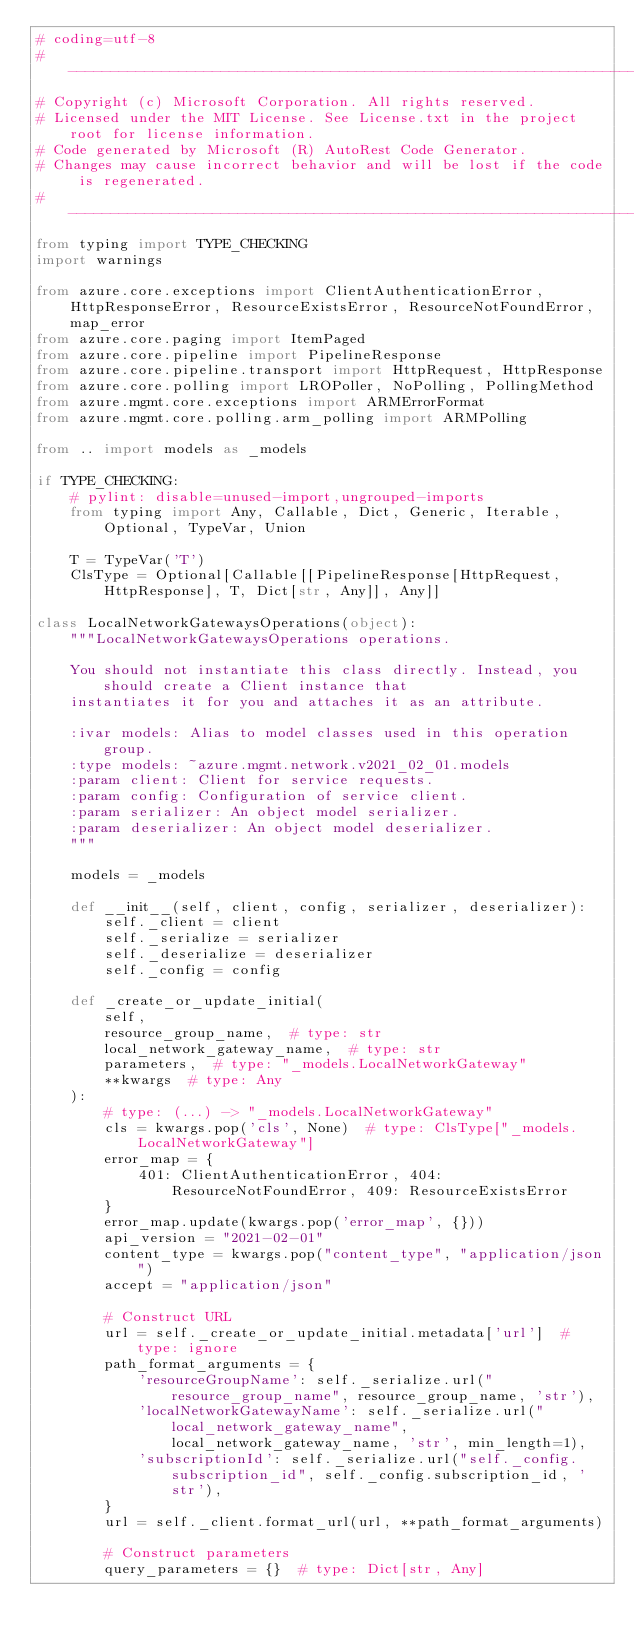<code> <loc_0><loc_0><loc_500><loc_500><_Python_># coding=utf-8
# --------------------------------------------------------------------------
# Copyright (c) Microsoft Corporation. All rights reserved.
# Licensed under the MIT License. See License.txt in the project root for license information.
# Code generated by Microsoft (R) AutoRest Code Generator.
# Changes may cause incorrect behavior and will be lost if the code is regenerated.
# --------------------------------------------------------------------------
from typing import TYPE_CHECKING
import warnings

from azure.core.exceptions import ClientAuthenticationError, HttpResponseError, ResourceExistsError, ResourceNotFoundError, map_error
from azure.core.paging import ItemPaged
from azure.core.pipeline import PipelineResponse
from azure.core.pipeline.transport import HttpRequest, HttpResponse
from azure.core.polling import LROPoller, NoPolling, PollingMethod
from azure.mgmt.core.exceptions import ARMErrorFormat
from azure.mgmt.core.polling.arm_polling import ARMPolling

from .. import models as _models

if TYPE_CHECKING:
    # pylint: disable=unused-import,ungrouped-imports
    from typing import Any, Callable, Dict, Generic, Iterable, Optional, TypeVar, Union

    T = TypeVar('T')
    ClsType = Optional[Callable[[PipelineResponse[HttpRequest, HttpResponse], T, Dict[str, Any]], Any]]

class LocalNetworkGatewaysOperations(object):
    """LocalNetworkGatewaysOperations operations.

    You should not instantiate this class directly. Instead, you should create a Client instance that
    instantiates it for you and attaches it as an attribute.

    :ivar models: Alias to model classes used in this operation group.
    :type models: ~azure.mgmt.network.v2021_02_01.models
    :param client: Client for service requests.
    :param config: Configuration of service client.
    :param serializer: An object model serializer.
    :param deserializer: An object model deserializer.
    """

    models = _models

    def __init__(self, client, config, serializer, deserializer):
        self._client = client
        self._serialize = serializer
        self._deserialize = deserializer
        self._config = config

    def _create_or_update_initial(
        self,
        resource_group_name,  # type: str
        local_network_gateway_name,  # type: str
        parameters,  # type: "_models.LocalNetworkGateway"
        **kwargs  # type: Any
    ):
        # type: (...) -> "_models.LocalNetworkGateway"
        cls = kwargs.pop('cls', None)  # type: ClsType["_models.LocalNetworkGateway"]
        error_map = {
            401: ClientAuthenticationError, 404: ResourceNotFoundError, 409: ResourceExistsError
        }
        error_map.update(kwargs.pop('error_map', {}))
        api_version = "2021-02-01"
        content_type = kwargs.pop("content_type", "application/json")
        accept = "application/json"

        # Construct URL
        url = self._create_or_update_initial.metadata['url']  # type: ignore
        path_format_arguments = {
            'resourceGroupName': self._serialize.url("resource_group_name", resource_group_name, 'str'),
            'localNetworkGatewayName': self._serialize.url("local_network_gateway_name", local_network_gateway_name, 'str', min_length=1),
            'subscriptionId': self._serialize.url("self._config.subscription_id", self._config.subscription_id, 'str'),
        }
        url = self._client.format_url(url, **path_format_arguments)

        # Construct parameters
        query_parameters = {}  # type: Dict[str, Any]</code> 